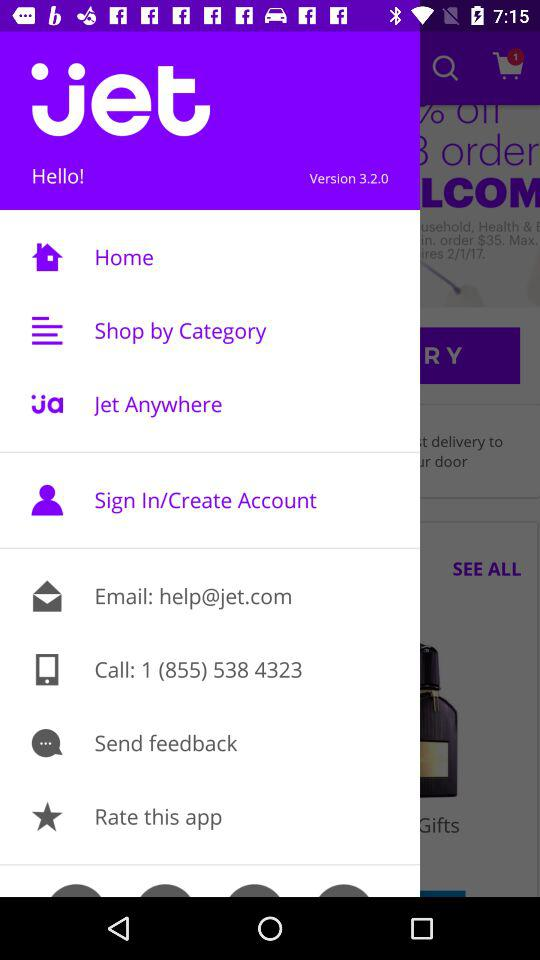What is the application name? The application name is ".jet". 